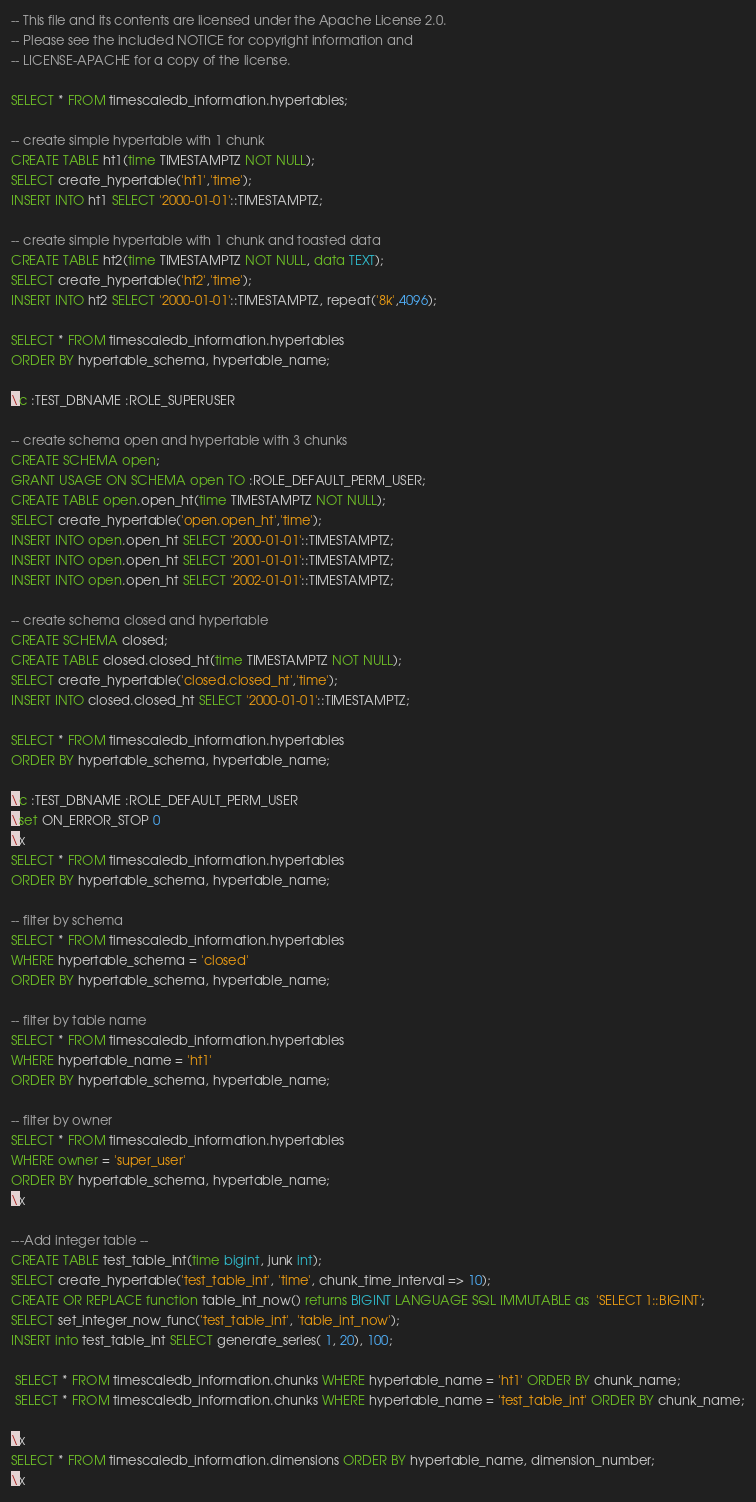<code> <loc_0><loc_0><loc_500><loc_500><_SQL_>-- This file and its contents are licensed under the Apache License 2.0.
-- Please see the included NOTICE for copyright information and
-- LICENSE-APACHE for a copy of the license.

SELECT * FROM timescaledb_information.hypertables;

-- create simple hypertable with 1 chunk
CREATE TABLE ht1(time TIMESTAMPTZ NOT NULL);
SELECT create_hypertable('ht1','time');
INSERT INTO ht1 SELECT '2000-01-01'::TIMESTAMPTZ;

-- create simple hypertable with 1 chunk and toasted data
CREATE TABLE ht2(time TIMESTAMPTZ NOT NULL, data TEXT);
SELECT create_hypertable('ht2','time');
INSERT INTO ht2 SELECT '2000-01-01'::TIMESTAMPTZ, repeat('8k',4096);

SELECT * FROM timescaledb_information.hypertables
ORDER BY hypertable_schema, hypertable_name;

\c :TEST_DBNAME :ROLE_SUPERUSER

-- create schema open and hypertable with 3 chunks
CREATE SCHEMA open;
GRANT USAGE ON SCHEMA open TO :ROLE_DEFAULT_PERM_USER;
CREATE TABLE open.open_ht(time TIMESTAMPTZ NOT NULL);
SELECT create_hypertable('open.open_ht','time');
INSERT INTO open.open_ht SELECT '2000-01-01'::TIMESTAMPTZ;
INSERT INTO open.open_ht SELECT '2001-01-01'::TIMESTAMPTZ;
INSERT INTO open.open_ht SELECT '2002-01-01'::TIMESTAMPTZ;

-- create schema closed and hypertable
CREATE SCHEMA closed;
CREATE TABLE closed.closed_ht(time TIMESTAMPTZ NOT NULL);
SELECT create_hypertable('closed.closed_ht','time');
INSERT INTO closed.closed_ht SELECT '2000-01-01'::TIMESTAMPTZ;

SELECT * FROM timescaledb_information.hypertables
ORDER BY hypertable_schema, hypertable_name;

\c :TEST_DBNAME :ROLE_DEFAULT_PERM_USER
\set ON_ERROR_STOP 0
\x
SELECT * FROM timescaledb_information.hypertables
ORDER BY hypertable_schema, hypertable_name;

-- filter by schema
SELECT * FROM timescaledb_information.hypertables
WHERE hypertable_schema = 'closed'
ORDER BY hypertable_schema, hypertable_name;

-- filter by table name
SELECT * FROM timescaledb_information.hypertables
WHERE hypertable_name = 'ht1'
ORDER BY hypertable_schema, hypertable_name;

-- filter by owner
SELECT * FROM timescaledb_information.hypertables
WHERE owner = 'super_user'
ORDER BY hypertable_schema, hypertable_name;
\x

---Add integer table --
CREATE TABLE test_table_int(time bigint, junk int);
SELECT create_hypertable('test_table_int', 'time', chunk_time_interval => 10);
CREATE OR REPLACE function table_int_now() returns BIGINT LANGUAGE SQL IMMUTABLE as  'SELECT 1::BIGINT';
SELECT set_integer_now_func('test_table_int', 'table_int_now');
INSERT into test_table_int SELECT generate_series( 1, 20), 100;

 SELECT * FROM timescaledb_information.chunks WHERE hypertable_name = 'ht1' ORDER BY chunk_name;
 SELECT * FROM timescaledb_information.chunks WHERE hypertable_name = 'test_table_int' ORDER BY chunk_name;

\x 
SELECT * FROM timescaledb_information.dimensions ORDER BY hypertable_name, dimension_number;
\x 
</code> 